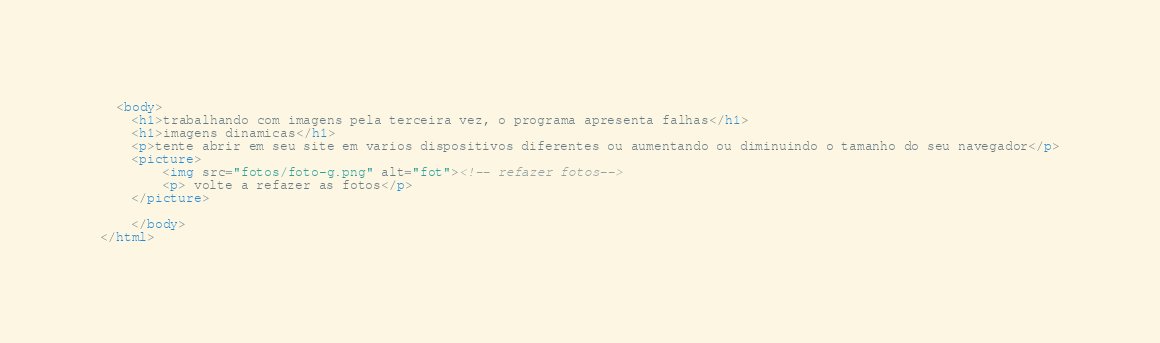<code> <loc_0><loc_0><loc_500><loc_500><_HTML_>  <body>
    <h1>trabalhando com imagens pela terceira vez, o programa apresenta falhas</h1>
    <h1>imagens dinamicas</h1>
    <p>tente abrir em seu site em varios dispositivos diferentes ou aumentando ou diminuindo o tamanho do seu navegador</p>
    <picture>
        <img src="fotos/foto-g.png" alt="fot"><!-- refazer fotos-->
        <p> volte a refazer as fotos</p>
    </picture>
        
    </body>
</html></code> 